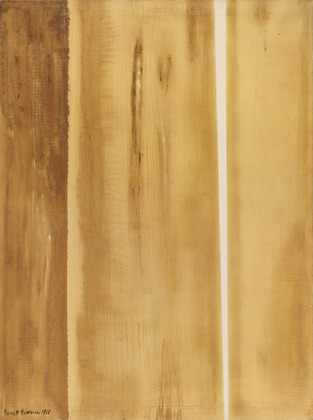If this painting was an instrument, what would it sound like? If this painting were an instrument, it would sound like a deep, resonating cello. The earthy colors would translate into rich, warm tones that evoke a sense of grounding and depth. The rough textures would be reflected in the cello’s ability to convey both smooth legato and gritty, emotional strokes. It would play melodies that are both soothing and haunting, capturing the complexity of human emotions and the natural world. 